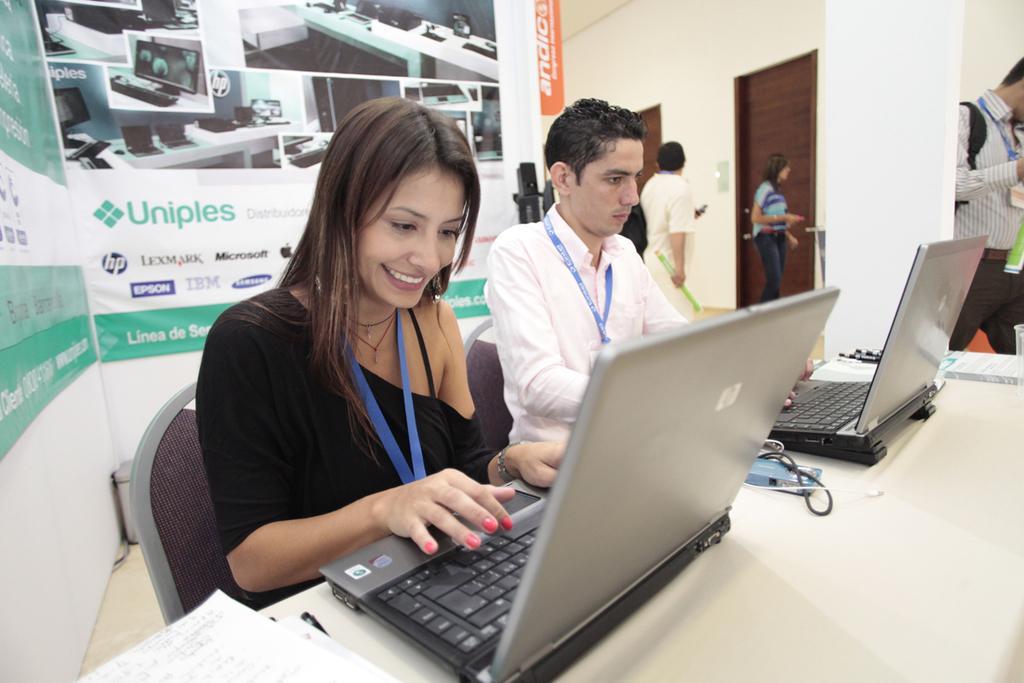In one or two sentences, can you explain what this image depicts? In this image we can see persons sitting on the chairs and some are standing on the floor. All the persons see working at the laptops. There is a table and on the table there are papers, cables and polythene tumblers. In the background we can see doors, walls and advertisement boards. 